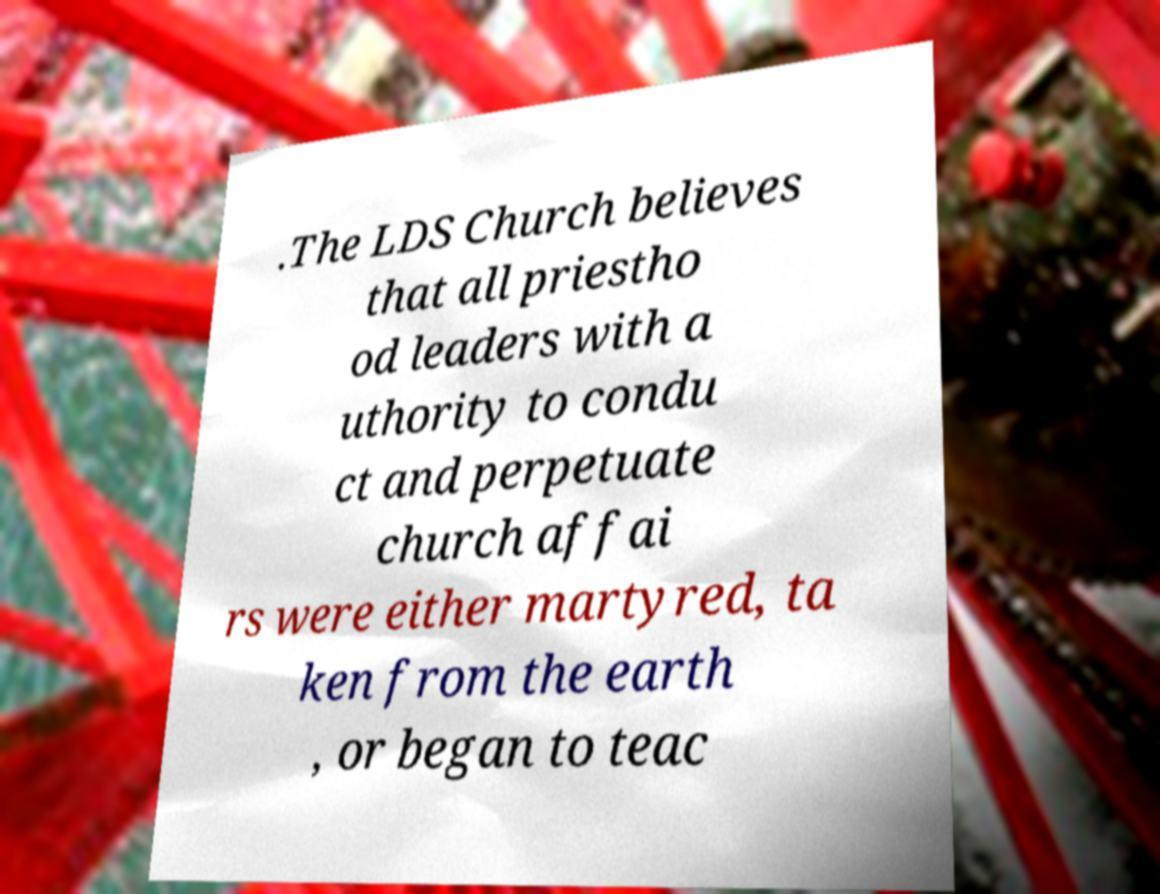Please identify and transcribe the text found in this image. .The LDS Church believes that all priestho od leaders with a uthority to condu ct and perpetuate church affai rs were either martyred, ta ken from the earth , or began to teac 